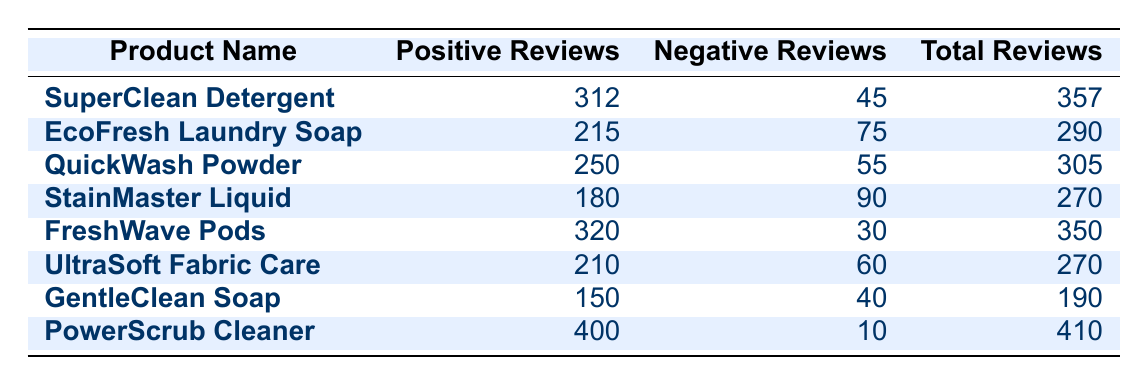What product received the most positive reviews? Referring to the "Positive Reviews" column, I can see that "PowerScrub Cleaner" has the highest value at 400.
Answer: PowerScrub Cleaner How many negative reviews did "SuperClean Detergent" receive? Looking directly at the "Negative Reviews" column for "SuperClean Detergent," the number of negative reviews is 45.
Answer: 45 Which product had the lowest total number of reviews? To find the product with the lowest total reviews, I will compare the "Total Reviews" column across all products. The product with the lowest total reviews is "GentleClean Soap" with 190 total reviews.
Answer: GentleClean Soap What is the average number of positive reviews across all products? I need to sum the positive reviews: 312 + 215 + 250 + 180 + 320 + 210 + 150 + 400 = 2037. There are 8 products, so I calculate 2037/8 = 254.625. Thus, the average number of positive reviews is approximately 255.
Answer: 255 Did "EcoFresh Laundry Soap" receive more negative reviews than "UltraSoft Fabric Care"? I will compare the negative reviews for both products. "EcoFresh Laundry Soap" has 75 negative reviews, while "UltraSoft Fabric Care" has 60 negative reviews. Since 75 is greater than 60, the statement is true.
Answer: Yes What is the difference in the number of positive reviews between "FreshWave Pods" and "QuickWash Powder"? I can calculate the difference by subtracting the positive reviews of "QuickWash Powder" (250) from those of "FreshWave Pods" (320). The difference is 320 - 250 = 70.
Answer: 70 Which product has the best ratio of positive to negative reviews? To find the best ratio, I will calculate the ratio for each product by dividing positive reviews by negative reviews. The highest ratio found is for "PowerScrub Cleaner," which has a ratio of 400/10 = 40.
Answer: PowerScrub Cleaner How many products received more than 200 positive reviews? By inspecting the "Positive Reviews" column, I can count the products: "SuperClean Detergent," "FreshWave Pods," "PowerScrub Cleaner," and "QuickWash Powder" all have more than 200 positive reviews. In total, that gives me 4 products.
Answer: 4 